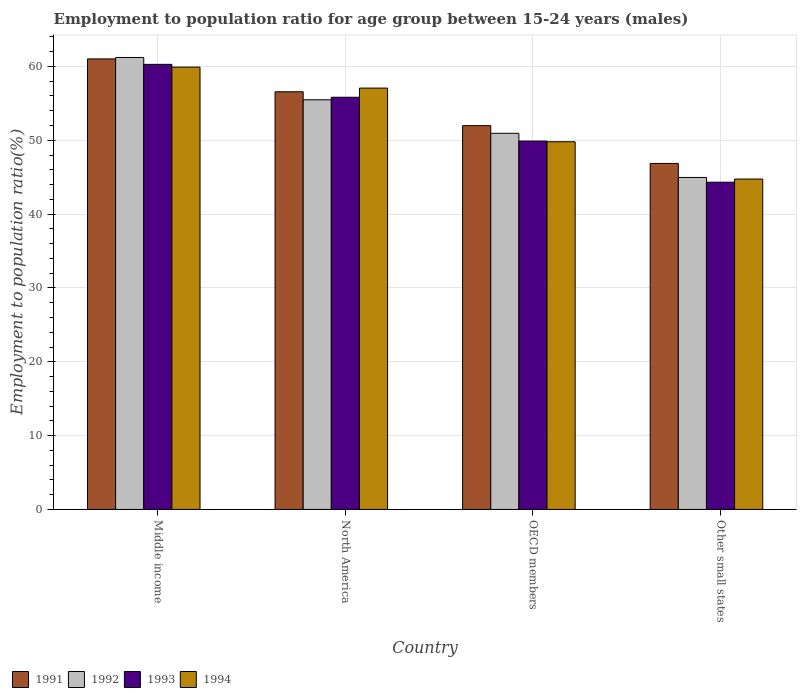How many groups of bars are there?
Offer a terse response. 4. What is the label of the 2nd group of bars from the left?
Keep it short and to the point. North America. In how many cases, is the number of bars for a given country not equal to the number of legend labels?
Your response must be concise. 0. What is the employment to population ratio in 1994 in North America?
Your answer should be compact. 57.07. Across all countries, what is the maximum employment to population ratio in 1993?
Your response must be concise. 60.28. Across all countries, what is the minimum employment to population ratio in 1993?
Provide a succinct answer. 44.32. In which country was the employment to population ratio in 1991 minimum?
Your answer should be compact. Other small states. What is the total employment to population ratio in 1992 in the graph?
Your answer should be very brief. 212.61. What is the difference between the employment to population ratio in 1993 in Middle income and that in Other small states?
Give a very brief answer. 15.96. What is the difference between the employment to population ratio in 1991 in Middle income and the employment to population ratio in 1993 in Other small states?
Keep it short and to the point. 16.7. What is the average employment to population ratio in 1993 per country?
Your answer should be compact. 52.58. What is the difference between the employment to population ratio of/in 1992 and employment to population ratio of/in 1994 in North America?
Make the answer very short. -1.59. In how many countries, is the employment to population ratio in 1991 greater than 14 %?
Give a very brief answer. 4. What is the ratio of the employment to population ratio in 1992 in Middle income to that in Other small states?
Offer a terse response. 1.36. Is the employment to population ratio in 1992 in OECD members less than that in Other small states?
Provide a succinct answer. No. What is the difference between the highest and the second highest employment to population ratio in 1993?
Your answer should be compact. -10.39. What is the difference between the highest and the lowest employment to population ratio in 1992?
Offer a terse response. 16.25. In how many countries, is the employment to population ratio in 1991 greater than the average employment to population ratio in 1991 taken over all countries?
Offer a terse response. 2. Is the sum of the employment to population ratio in 1992 in Middle income and Other small states greater than the maximum employment to population ratio in 1993 across all countries?
Your answer should be very brief. Yes. Is it the case that in every country, the sum of the employment to population ratio in 1992 and employment to population ratio in 1991 is greater than the sum of employment to population ratio in 1993 and employment to population ratio in 1994?
Your answer should be very brief. No. What does the 3rd bar from the left in North America represents?
Provide a succinct answer. 1993. Is it the case that in every country, the sum of the employment to population ratio in 1993 and employment to population ratio in 1992 is greater than the employment to population ratio in 1991?
Your response must be concise. Yes. How many bars are there?
Make the answer very short. 16. Are all the bars in the graph horizontal?
Make the answer very short. No. What is the difference between two consecutive major ticks on the Y-axis?
Offer a very short reply. 10. Does the graph contain any zero values?
Offer a very short reply. No. Does the graph contain grids?
Your answer should be very brief. Yes. What is the title of the graph?
Make the answer very short. Employment to population ratio for age group between 15-24 years (males). What is the Employment to population ratio(%) in 1991 in Middle income?
Ensure brevity in your answer.  61.02. What is the Employment to population ratio(%) in 1992 in Middle income?
Keep it short and to the point. 61.21. What is the Employment to population ratio(%) in 1993 in Middle income?
Your response must be concise. 60.28. What is the Employment to population ratio(%) in 1994 in Middle income?
Your answer should be very brief. 59.91. What is the Employment to population ratio(%) of 1991 in North America?
Offer a terse response. 56.57. What is the Employment to population ratio(%) of 1992 in North America?
Your response must be concise. 55.48. What is the Employment to population ratio(%) in 1993 in North America?
Your answer should be compact. 55.83. What is the Employment to population ratio(%) of 1994 in North America?
Provide a succinct answer. 57.07. What is the Employment to population ratio(%) in 1991 in OECD members?
Your answer should be compact. 51.98. What is the Employment to population ratio(%) of 1992 in OECD members?
Keep it short and to the point. 50.95. What is the Employment to population ratio(%) in 1993 in OECD members?
Your answer should be compact. 49.89. What is the Employment to population ratio(%) of 1994 in OECD members?
Offer a very short reply. 49.8. What is the Employment to population ratio(%) in 1991 in Other small states?
Offer a very short reply. 46.86. What is the Employment to population ratio(%) in 1992 in Other small states?
Your answer should be compact. 44.96. What is the Employment to population ratio(%) of 1993 in Other small states?
Your answer should be compact. 44.32. What is the Employment to population ratio(%) in 1994 in Other small states?
Provide a short and direct response. 44.75. Across all countries, what is the maximum Employment to population ratio(%) in 1991?
Your answer should be very brief. 61.02. Across all countries, what is the maximum Employment to population ratio(%) in 1992?
Provide a succinct answer. 61.21. Across all countries, what is the maximum Employment to population ratio(%) of 1993?
Provide a succinct answer. 60.28. Across all countries, what is the maximum Employment to population ratio(%) in 1994?
Your answer should be compact. 59.91. Across all countries, what is the minimum Employment to population ratio(%) of 1991?
Provide a succinct answer. 46.86. Across all countries, what is the minimum Employment to population ratio(%) of 1992?
Your answer should be very brief. 44.96. Across all countries, what is the minimum Employment to population ratio(%) of 1993?
Your answer should be compact. 44.32. Across all countries, what is the minimum Employment to population ratio(%) of 1994?
Your response must be concise. 44.75. What is the total Employment to population ratio(%) in 1991 in the graph?
Your answer should be very brief. 216.43. What is the total Employment to population ratio(%) of 1992 in the graph?
Ensure brevity in your answer.  212.61. What is the total Employment to population ratio(%) of 1993 in the graph?
Make the answer very short. 210.32. What is the total Employment to population ratio(%) of 1994 in the graph?
Ensure brevity in your answer.  211.53. What is the difference between the Employment to population ratio(%) in 1991 in Middle income and that in North America?
Provide a short and direct response. 4.45. What is the difference between the Employment to population ratio(%) of 1992 in Middle income and that in North America?
Provide a succinct answer. 5.73. What is the difference between the Employment to population ratio(%) in 1993 in Middle income and that in North America?
Your answer should be compact. 4.46. What is the difference between the Employment to population ratio(%) in 1994 in Middle income and that in North America?
Your answer should be very brief. 2.84. What is the difference between the Employment to population ratio(%) in 1991 in Middle income and that in OECD members?
Your response must be concise. 9.04. What is the difference between the Employment to population ratio(%) in 1992 in Middle income and that in OECD members?
Your answer should be very brief. 10.27. What is the difference between the Employment to population ratio(%) of 1993 in Middle income and that in OECD members?
Offer a terse response. 10.39. What is the difference between the Employment to population ratio(%) of 1994 in Middle income and that in OECD members?
Provide a succinct answer. 10.11. What is the difference between the Employment to population ratio(%) of 1991 in Middle income and that in Other small states?
Ensure brevity in your answer.  14.16. What is the difference between the Employment to population ratio(%) of 1992 in Middle income and that in Other small states?
Provide a succinct answer. 16.25. What is the difference between the Employment to population ratio(%) in 1993 in Middle income and that in Other small states?
Make the answer very short. 15.96. What is the difference between the Employment to population ratio(%) of 1994 in Middle income and that in Other small states?
Your response must be concise. 15.16. What is the difference between the Employment to population ratio(%) of 1991 in North America and that in OECD members?
Provide a succinct answer. 4.59. What is the difference between the Employment to population ratio(%) in 1992 in North America and that in OECD members?
Make the answer very short. 4.54. What is the difference between the Employment to population ratio(%) of 1993 in North America and that in OECD members?
Ensure brevity in your answer.  5.93. What is the difference between the Employment to population ratio(%) of 1994 in North America and that in OECD members?
Make the answer very short. 7.27. What is the difference between the Employment to population ratio(%) in 1991 in North America and that in Other small states?
Your answer should be compact. 9.7. What is the difference between the Employment to population ratio(%) in 1992 in North America and that in Other small states?
Your answer should be compact. 10.52. What is the difference between the Employment to population ratio(%) of 1993 in North America and that in Other small states?
Keep it short and to the point. 11.51. What is the difference between the Employment to population ratio(%) of 1994 in North America and that in Other small states?
Ensure brevity in your answer.  12.32. What is the difference between the Employment to population ratio(%) in 1991 in OECD members and that in Other small states?
Keep it short and to the point. 5.12. What is the difference between the Employment to population ratio(%) of 1992 in OECD members and that in Other small states?
Ensure brevity in your answer.  5.98. What is the difference between the Employment to population ratio(%) in 1993 in OECD members and that in Other small states?
Your response must be concise. 5.57. What is the difference between the Employment to population ratio(%) of 1994 in OECD members and that in Other small states?
Ensure brevity in your answer.  5.05. What is the difference between the Employment to population ratio(%) in 1991 in Middle income and the Employment to population ratio(%) in 1992 in North America?
Offer a terse response. 5.54. What is the difference between the Employment to population ratio(%) in 1991 in Middle income and the Employment to population ratio(%) in 1993 in North America?
Keep it short and to the point. 5.19. What is the difference between the Employment to population ratio(%) in 1991 in Middle income and the Employment to population ratio(%) in 1994 in North America?
Make the answer very short. 3.95. What is the difference between the Employment to population ratio(%) in 1992 in Middle income and the Employment to population ratio(%) in 1993 in North America?
Your answer should be very brief. 5.39. What is the difference between the Employment to population ratio(%) in 1992 in Middle income and the Employment to population ratio(%) in 1994 in North America?
Your response must be concise. 4.15. What is the difference between the Employment to population ratio(%) of 1993 in Middle income and the Employment to population ratio(%) of 1994 in North America?
Give a very brief answer. 3.21. What is the difference between the Employment to population ratio(%) of 1991 in Middle income and the Employment to population ratio(%) of 1992 in OECD members?
Your response must be concise. 10.07. What is the difference between the Employment to population ratio(%) in 1991 in Middle income and the Employment to population ratio(%) in 1993 in OECD members?
Offer a very short reply. 11.13. What is the difference between the Employment to population ratio(%) of 1991 in Middle income and the Employment to population ratio(%) of 1994 in OECD members?
Ensure brevity in your answer.  11.22. What is the difference between the Employment to population ratio(%) in 1992 in Middle income and the Employment to population ratio(%) in 1993 in OECD members?
Give a very brief answer. 11.32. What is the difference between the Employment to population ratio(%) in 1992 in Middle income and the Employment to population ratio(%) in 1994 in OECD members?
Offer a terse response. 11.41. What is the difference between the Employment to population ratio(%) of 1993 in Middle income and the Employment to population ratio(%) of 1994 in OECD members?
Your answer should be compact. 10.48. What is the difference between the Employment to population ratio(%) in 1991 in Middle income and the Employment to population ratio(%) in 1992 in Other small states?
Offer a terse response. 16.06. What is the difference between the Employment to population ratio(%) of 1991 in Middle income and the Employment to population ratio(%) of 1993 in Other small states?
Provide a short and direct response. 16.7. What is the difference between the Employment to population ratio(%) of 1991 in Middle income and the Employment to population ratio(%) of 1994 in Other small states?
Your response must be concise. 16.27. What is the difference between the Employment to population ratio(%) of 1992 in Middle income and the Employment to population ratio(%) of 1993 in Other small states?
Your answer should be very brief. 16.89. What is the difference between the Employment to population ratio(%) of 1992 in Middle income and the Employment to population ratio(%) of 1994 in Other small states?
Your answer should be very brief. 16.46. What is the difference between the Employment to population ratio(%) in 1993 in Middle income and the Employment to population ratio(%) in 1994 in Other small states?
Ensure brevity in your answer.  15.53. What is the difference between the Employment to population ratio(%) of 1991 in North America and the Employment to population ratio(%) of 1992 in OECD members?
Your answer should be compact. 5.62. What is the difference between the Employment to population ratio(%) of 1991 in North America and the Employment to population ratio(%) of 1993 in OECD members?
Your response must be concise. 6.68. What is the difference between the Employment to population ratio(%) of 1991 in North America and the Employment to population ratio(%) of 1994 in OECD members?
Offer a terse response. 6.77. What is the difference between the Employment to population ratio(%) in 1992 in North America and the Employment to population ratio(%) in 1993 in OECD members?
Offer a terse response. 5.59. What is the difference between the Employment to population ratio(%) of 1992 in North America and the Employment to population ratio(%) of 1994 in OECD members?
Your response must be concise. 5.68. What is the difference between the Employment to population ratio(%) of 1993 in North America and the Employment to population ratio(%) of 1994 in OECD members?
Your answer should be very brief. 6.03. What is the difference between the Employment to population ratio(%) in 1991 in North America and the Employment to population ratio(%) in 1992 in Other small states?
Provide a short and direct response. 11.61. What is the difference between the Employment to population ratio(%) of 1991 in North America and the Employment to population ratio(%) of 1993 in Other small states?
Keep it short and to the point. 12.25. What is the difference between the Employment to population ratio(%) of 1991 in North America and the Employment to population ratio(%) of 1994 in Other small states?
Provide a succinct answer. 11.82. What is the difference between the Employment to population ratio(%) in 1992 in North America and the Employment to population ratio(%) in 1993 in Other small states?
Offer a very short reply. 11.16. What is the difference between the Employment to population ratio(%) of 1992 in North America and the Employment to population ratio(%) of 1994 in Other small states?
Keep it short and to the point. 10.73. What is the difference between the Employment to population ratio(%) in 1993 in North America and the Employment to population ratio(%) in 1994 in Other small states?
Provide a short and direct response. 11.08. What is the difference between the Employment to population ratio(%) of 1991 in OECD members and the Employment to population ratio(%) of 1992 in Other small states?
Provide a succinct answer. 7.02. What is the difference between the Employment to population ratio(%) of 1991 in OECD members and the Employment to population ratio(%) of 1993 in Other small states?
Provide a short and direct response. 7.66. What is the difference between the Employment to population ratio(%) in 1991 in OECD members and the Employment to population ratio(%) in 1994 in Other small states?
Your answer should be very brief. 7.23. What is the difference between the Employment to population ratio(%) in 1992 in OECD members and the Employment to population ratio(%) in 1993 in Other small states?
Offer a terse response. 6.63. What is the difference between the Employment to population ratio(%) of 1992 in OECD members and the Employment to population ratio(%) of 1994 in Other small states?
Provide a short and direct response. 6.2. What is the difference between the Employment to population ratio(%) in 1993 in OECD members and the Employment to population ratio(%) in 1994 in Other small states?
Your response must be concise. 5.14. What is the average Employment to population ratio(%) of 1991 per country?
Provide a succinct answer. 54.11. What is the average Employment to population ratio(%) in 1992 per country?
Your answer should be very brief. 53.15. What is the average Employment to population ratio(%) of 1993 per country?
Keep it short and to the point. 52.58. What is the average Employment to population ratio(%) of 1994 per country?
Offer a very short reply. 52.88. What is the difference between the Employment to population ratio(%) in 1991 and Employment to population ratio(%) in 1992 in Middle income?
Provide a succinct answer. -0.19. What is the difference between the Employment to population ratio(%) in 1991 and Employment to population ratio(%) in 1993 in Middle income?
Make the answer very short. 0.74. What is the difference between the Employment to population ratio(%) in 1991 and Employment to population ratio(%) in 1994 in Middle income?
Offer a terse response. 1.11. What is the difference between the Employment to population ratio(%) in 1992 and Employment to population ratio(%) in 1993 in Middle income?
Give a very brief answer. 0.93. What is the difference between the Employment to population ratio(%) of 1992 and Employment to population ratio(%) of 1994 in Middle income?
Provide a succinct answer. 1.3. What is the difference between the Employment to population ratio(%) in 1993 and Employment to population ratio(%) in 1994 in Middle income?
Ensure brevity in your answer.  0.37. What is the difference between the Employment to population ratio(%) in 1991 and Employment to population ratio(%) in 1992 in North America?
Your answer should be very brief. 1.09. What is the difference between the Employment to population ratio(%) in 1991 and Employment to population ratio(%) in 1993 in North America?
Offer a terse response. 0.74. What is the difference between the Employment to population ratio(%) in 1991 and Employment to population ratio(%) in 1994 in North America?
Offer a very short reply. -0.5. What is the difference between the Employment to population ratio(%) of 1992 and Employment to population ratio(%) of 1993 in North America?
Ensure brevity in your answer.  -0.34. What is the difference between the Employment to population ratio(%) in 1992 and Employment to population ratio(%) in 1994 in North America?
Make the answer very short. -1.59. What is the difference between the Employment to population ratio(%) of 1993 and Employment to population ratio(%) of 1994 in North America?
Give a very brief answer. -1.24. What is the difference between the Employment to population ratio(%) in 1991 and Employment to population ratio(%) in 1992 in OECD members?
Make the answer very short. 1.03. What is the difference between the Employment to population ratio(%) in 1991 and Employment to population ratio(%) in 1993 in OECD members?
Offer a terse response. 2.09. What is the difference between the Employment to population ratio(%) in 1991 and Employment to population ratio(%) in 1994 in OECD members?
Ensure brevity in your answer.  2.18. What is the difference between the Employment to population ratio(%) of 1992 and Employment to population ratio(%) of 1993 in OECD members?
Ensure brevity in your answer.  1.05. What is the difference between the Employment to population ratio(%) in 1992 and Employment to population ratio(%) in 1994 in OECD members?
Keep it short and to the point. 1.15. What is the difference between the Employment to population ratio(%) of 1993 and Employment to population ratio(%) of 1994 in OECD members?
Provide a succinct answer. 0.09. What is the difference between the Employment to population ratio(%) in 1991 and Employment to population ratio(%) in 1992 in Other small states?
Your answer should be very brief. 1.9. What is the difference between the Employment to population ratio(%) of 1991 and Employment to population ratio(%) of 1993 in Other small states?
Provide a succinct answer. 2.54. What is the difference between the Employment to population ratio(%) in 1991 and Employment to population ratio(%) in 1994 in Other small states?
Offer a terse response. 2.11. What is the difference between the Employment to population ratio(%) in 1992 and Employment to population ratio(%) in 1993 in Other small states?
Ensure brevity in your answer.  0.64. What is the difference between the Employment to population ratio(%) in 1992 and Employment to population ratio(%) in 1994 in Other small states?
Make the answer very short. 0.21. What is the difference between the Employment to population ratio(%) in 1993 and Employment to population ratio(%) in 1994 in Other small states?
Give a very brief answer. -0.43. What is the ratio of the Employment to population ratio(%) of 1991 in Middle income to that in North America?
Keep it short and to the point. 1.08. What is the ratio of the Employment to population ratio(%) in 1992 in Middle income to that in North America?
Offer a very short reply. 1.1. What is the ratio of the Employment to population ratio(%) of 1993 in Middle income to that in North America?
Make the answer very short. 1.08. What is the ratio of the Employment to population ratio(%) in 1994 in Middle income to that in North America?
Offer a terse response. 1.05. What is the ratio of the Employment to population ratio(%) in 1991 in Middle income to that in OECD members?
Your response must be concise. 1.17. What is the ratio of the Employment to population ratio(%) in 1992 in Middle income to that in OECD members?
Ensure brevity in your answer.  1.2. What is the ratio of the Employment to population ratio(%) of 1993 in Middle income to that in OECD members?
Keep it short and to the point. 1.21. What is the ratio of the Employment to population ratio(%) of 1994 in Middle income to that in OECD members?
Make the answer very short. 1.2. What is the ratio of the Employment to population ratio(%) in 1991 in Middle income to that in Other small states?
Provide a succinct answer. 1.3. What is the ratio of the Employment to population ratio(%) in 1992 in Middle income to that in Other small states?
Your response must be concise. 1.36. What is the ratio of the Employment to population ratio(%) in 1993 in Middle income to that in Other small states?
Make the answer very short. 1.36. What is the ratio of the Employment to population ratio(%) in 1994 in Middle income to that in Other small states?
Make the answer very short. 1.34. What is the ratio of the Employment to population ratio(%) in 1991 in North America to that in OECD members?
Offer a very short reply. 1.09. What is the ratio of the Employment to population ratio(%) of 1992 in North America to that in OECD members?
Your response must be concise. 1.09. What is the ratio of the Employment to population ratio(%) of 1993 in North America to that in OECD members?
Your response must be concise. 1.12. What is the ratio of the Employment to population ratio(%) in 1994 in North America to that in OECD members?
Provide a short and direct response. 1.15. What is the ratio of the Employment to population ratio(%) of 1991 in North America to that in Other small states?
Ensure brevity in your answer.  1.21. What is the ratio of the Employment to population ratio(%) in 1992 in North America to that in Other small states?
Your answer should be compact. 1.23. What is the ratio of the Employment to population ratio(%) of 1993 in North America to that in Other small states?
Provide a short and direct response. 1.26. What is the ratio of the Employment to population ratio(%) in 1994 in North America to that in Other small states?
Your answer should be very brief. 1.28. What is the ratio of the Employment to population ratio(%) in 1991 in OECD members to that in Other small states?
Make the answer very short. 1.11. What is the ratio of the Employment to population ratio(%) in 1992 in OECD members to that in Other small states?
Your answer should be very brief. 1.13. What is the ratio of the Employment to population ratio(%) in 1993 in OECD members to that in Other small states?
Make the answer very short. 1.13. What is the ratio of the Employment to population ratio(%) of 1994 in OECD members to that in Other small states?
Your answer should be very brief. 1.11. What is the difference between the highest and the second highest Employment to population ratio(%) in 1991?
Give a very brief answer. 4.45. What is the difference between the highest and the second highest Employment to population ratio(%) of 1992?
Your response must be concise. 5.73. What is the difference between the highest and the second highest Employment to population ratio(%) of 1993?
Make the answer very short. 4.46. What is the difference between the highest and the second highest Employment to population ratio(%) of 1994?
Keep it short and to the point. 2.84. What is the difference between the highest and the lowest Employment to population ratio(%) in 1991?
Provide a short and direct response. 14.16. What is the difference between the highest and the lowest Employment to population ratio(%) in 1992?
Ensure brevity in your answer.  16.25. What is the difference between the highest and the lowest Employment to population ratio(%) of 1993?
Ensure brevity in your answer.  15.96. What is the difference between the highest and the lowest Employment to population ratio(%) in 1994?
Provide a succinct answer. 15.16. 